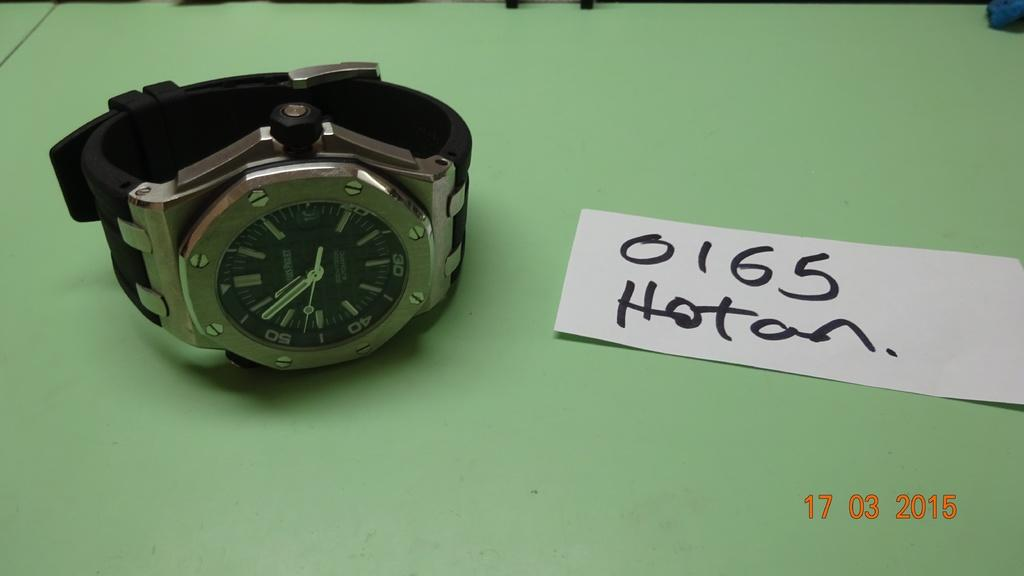<image>
Render a clear and concise summary of the photo. A white piece of paper next to a watch says "0165 Hotan". 